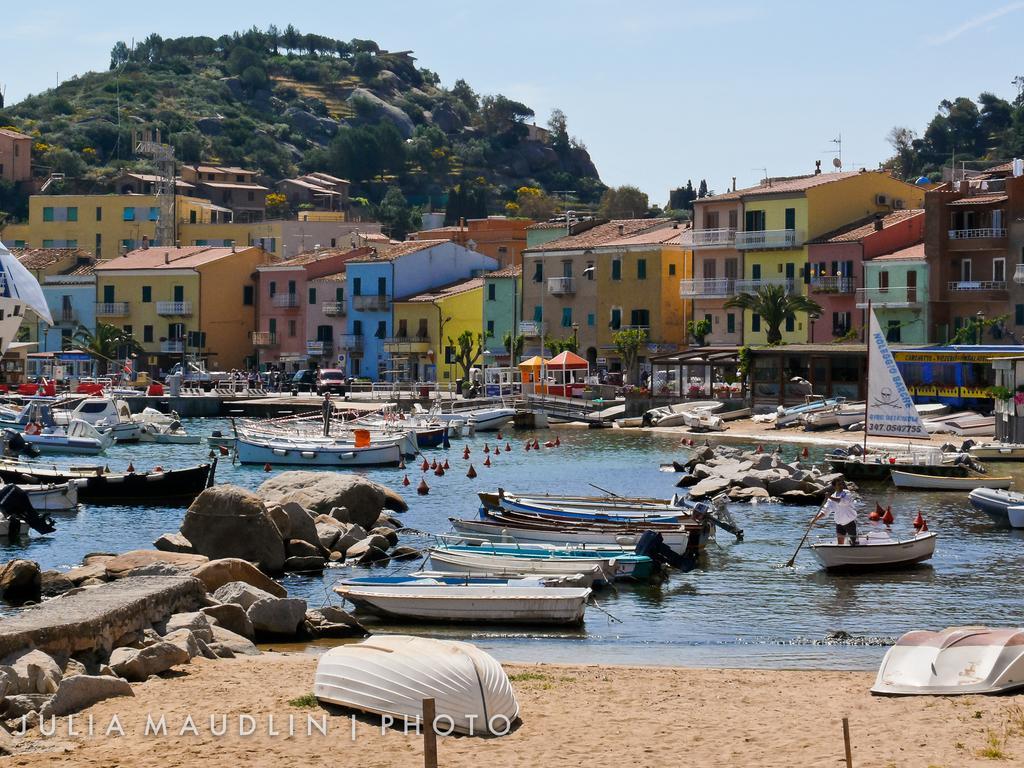Could you give a brief overview of what you see in this image? In this image, there are a few buildings, trees, people, vehicles, poles, sheds. We can also see some boats and objects sailing on the water. We can also see a hill, some plants and rocks. We can see the sky and the ground with some objects. We can also see some text at the bottom. We can see a flag. 